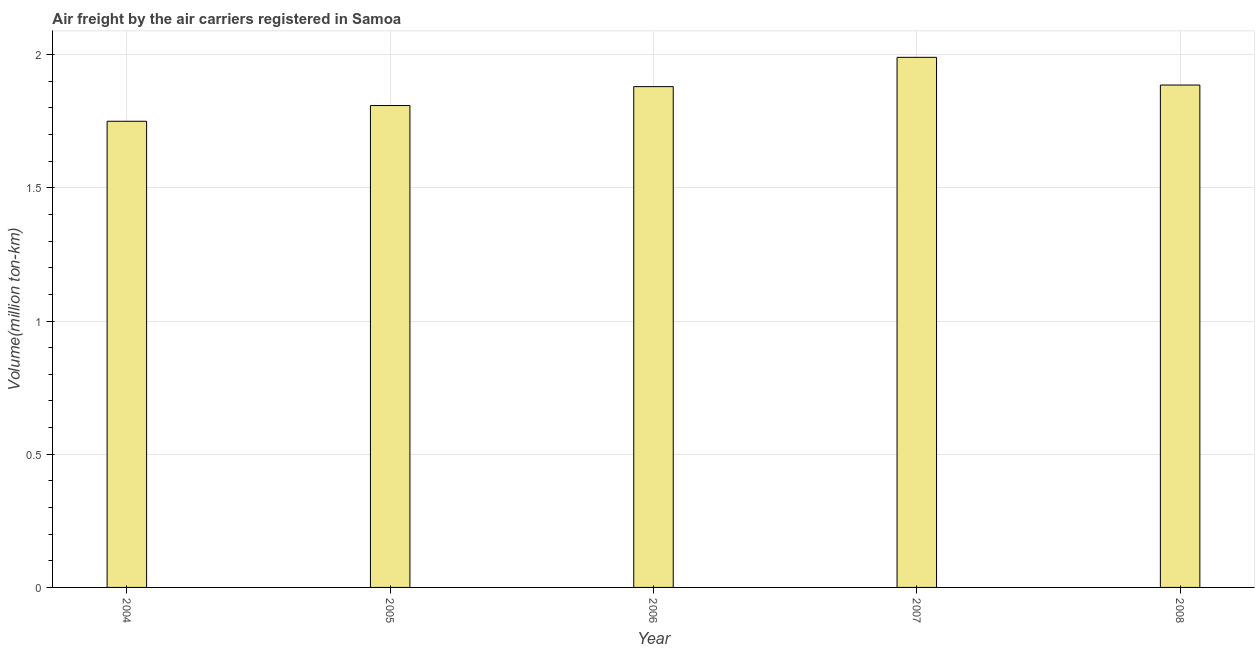What is the title of the graph?
Make the answer very short. Air freight by the air carriers registered in Samoa. What is the label or title of the Y-axis?
Your response must be concise. Volume(million ton-km). What is the air freight in 2006?
Provide a short and direct response. 1.88. Across all years, what is the maximum air freight?
Your answer should be very brief. 1.99. Across all years, what is the minimum air freight?
Offer a terse response. 1.75. What is the sum of the air freight?
Offer a terse response. 9.31. What is the difference between the air freight in 2006 and 2008?
Your response must be concise. -0.01. What is the average air freight per year?
Your answer should be compact. 1.86. What is the median air freight?
Keep it short and to the point. 1.88. Do a majority of the years between 2004 and 2005 (inclusive) have air freight greater than 0.7 million ton-km?
Provide a short and direct response. Yes. What is the ratio of the air freight in 2005 to that in 2008?
Offer a terse response. 0.96. Is the air freight in 2005 less than that in 2006?
Provide a short and direct response. Yes. What is the difference between the highest and the second highest air freight?
Give a very brief answer. 0.1. Is the sum of the air freight in 2006 and 2007 greater than the maximum air freight across all years?
Keep it short and to the point. Yes. What is the difference between the highest and the lowest air freight?
Keep it short and to the point. 0.24. In how many years, is the air freight greater than the average air freight taken over all years?
Ensure brevity in your answer.  3. How many bars are there?
Keep it short and to the point. 5. What is the difference between two consecutive major ticks on the Y-axis?
Your response must be concise. 0.5. What is the Volume(million ton-km) in 2004?
Your answer should be very brief. 1.75. What is the Volume(million ton-km) of 2005?
Your answer should be very brief. 1.81. What is the Volume(million ton-km) in 2006?
Your response must be concise. 1.88. What is the Volume(million ton-km) in 2007?
Offer a very short reply. 1.99. What is the Volume(million ton-km) of 2008?
Your answer should be very brief. 1.89. What is the difference between the Volume(million ton-km) in 2004 and 2005?
Ensure brevity in your answer.  -0.06. What is the difference between the Volume(million ton-km) in 2004 and 2006?
Ensure brevity in your answer.  -0.13. What is the difference between the Volume(million ton-km) in 2004 and 2007?
Keep it short and to the point. -0.24. What is the difference between the Volume(million ton-km) in 2004 and 2008?
Ensure brevity in your answer.  -0.14. What is the difference between the Volume(million ton-km) in 2005 and 2006?
Your answer should be very brief. -0.07. What is the difference between the Volume(million ton-km) in 2005 and 2007?
Your answer should be very brief. -0.18. What is the difference between the Volume(million ton-km) in 2005 and 2008?
Provide a short and direct response. -0.08. What is the difference between the Volume(million ton-km) in 2006 and 2007?
Your answer should be compact. -0.11. What is the difference between the Volume(million ton-km) in 2006 and 2008?
Your answer should be very brief. -0.01. What is the difference between the Volume(million ton-km) in 2007 and 2008?
Your answer should be compact. 0.1. What is the ratio of the Volume(million ton-km) in 2004 to that in 2007?
Make the answer very short. 0.88. What is the ratio of the Volume(million ton-km) in 2004 to that in 2008?
Ensure brevity in your answer.  0.93. What is the ratio of the Volume(million ton-km) in 2005 to that in 2006?
Provide a succinct answer. 0.96. What is the ratio of the Volume(million ton-km) in 2005 to that in 2007?
Your response must be concise. 0.91. What is the ratio of the Volume(million ton-km) in 2006 to that in 2007?
Give a very brief answer. 0.94. What is the ratio of the Volume(million ton-km) in 2007 to that in 2008?
Make the answer very short. 1.05. 